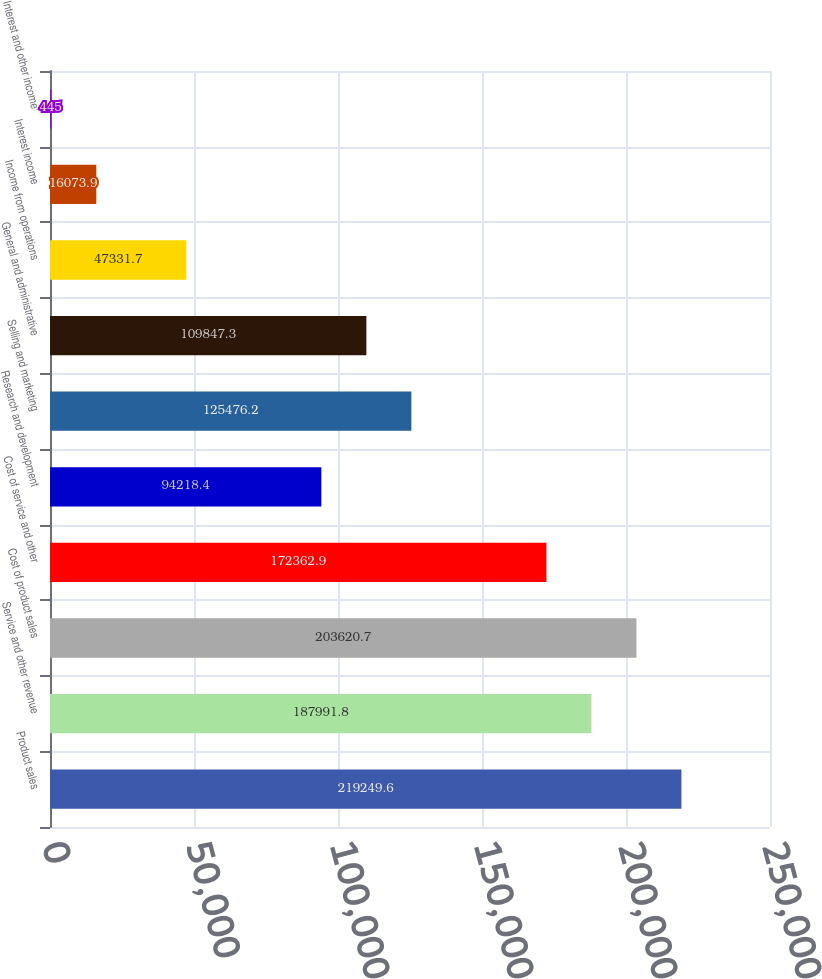Convert chart. <chart><loc_0><loc_0><loc_500><loc_500><bar_chart><fcel>Product sales<fcel>Service and other revenue<fcel>Cost of product sales<fcel>Cost of service and other<fcel>Research and development<fcel>Selling and marketing<fcel>General and administrative<fcel>Income from operations<fcel>Interest income<fcel>Interest and other income<nl><fcel>219250<fcel>187992<fcel>203621<fcel>172363<fcel>94218.4<fcel>125476<fcel>109847<fcel>47331.7<fcel>16073.9<fcel>445<nl></chart> 